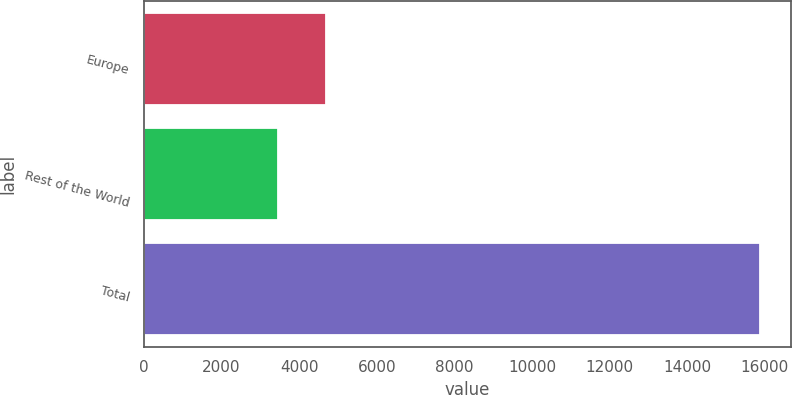Convert chart. <chart><loc_0><loc_0><loc_500><loc_500><bar_chart><fcel>Europe<fcel>Rest of the World<fcel>Total<nl><fcel>4701<fcel>3459<fcel>15879<nl></chart> 